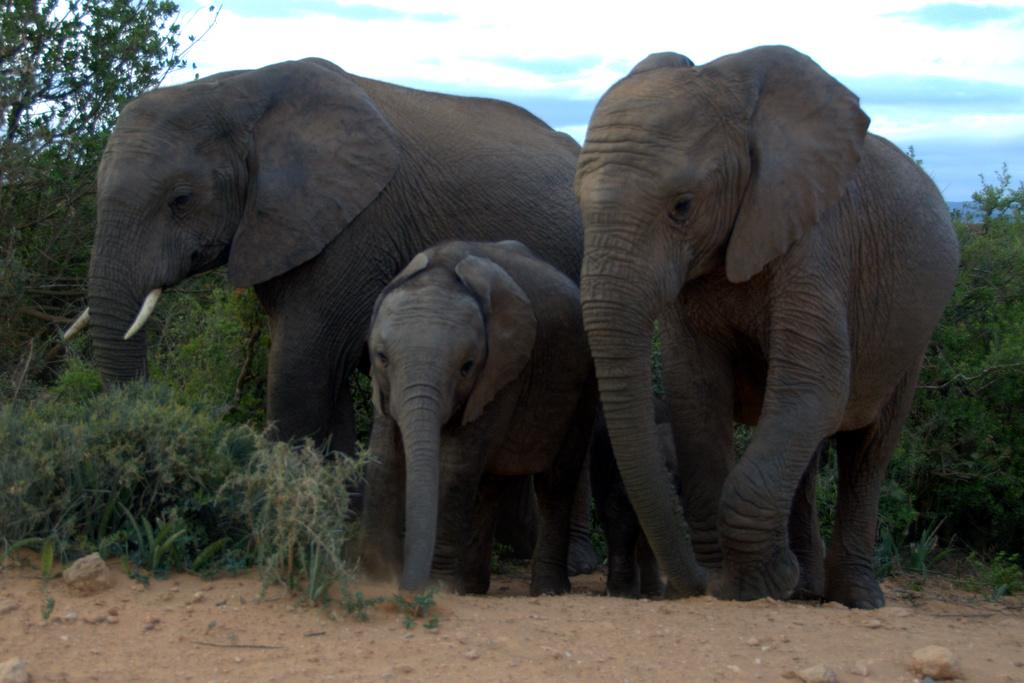What animals are present in the image? There are elephants in the image. What can be seen in the background of the image? There are trees and a blue sky in the background of the image. Can you see any patches on the elephants in the image? There is no mention of patches on the elephants in the image, so we cannot determine if they have any patches. 